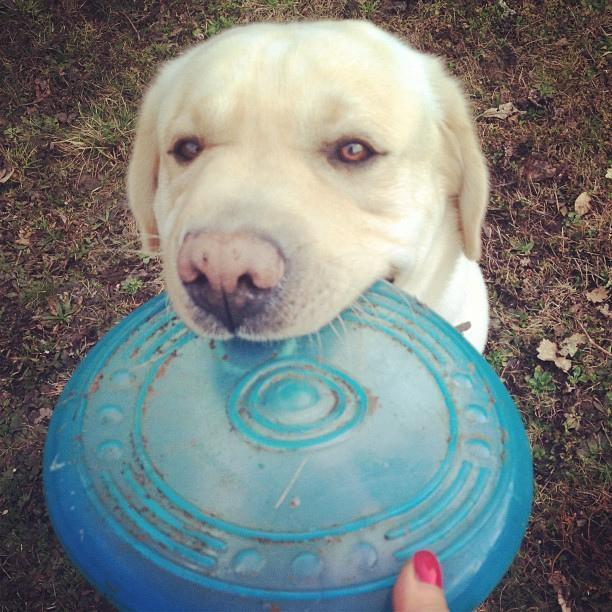How many people are there?
Give a very brief answer. 1. 